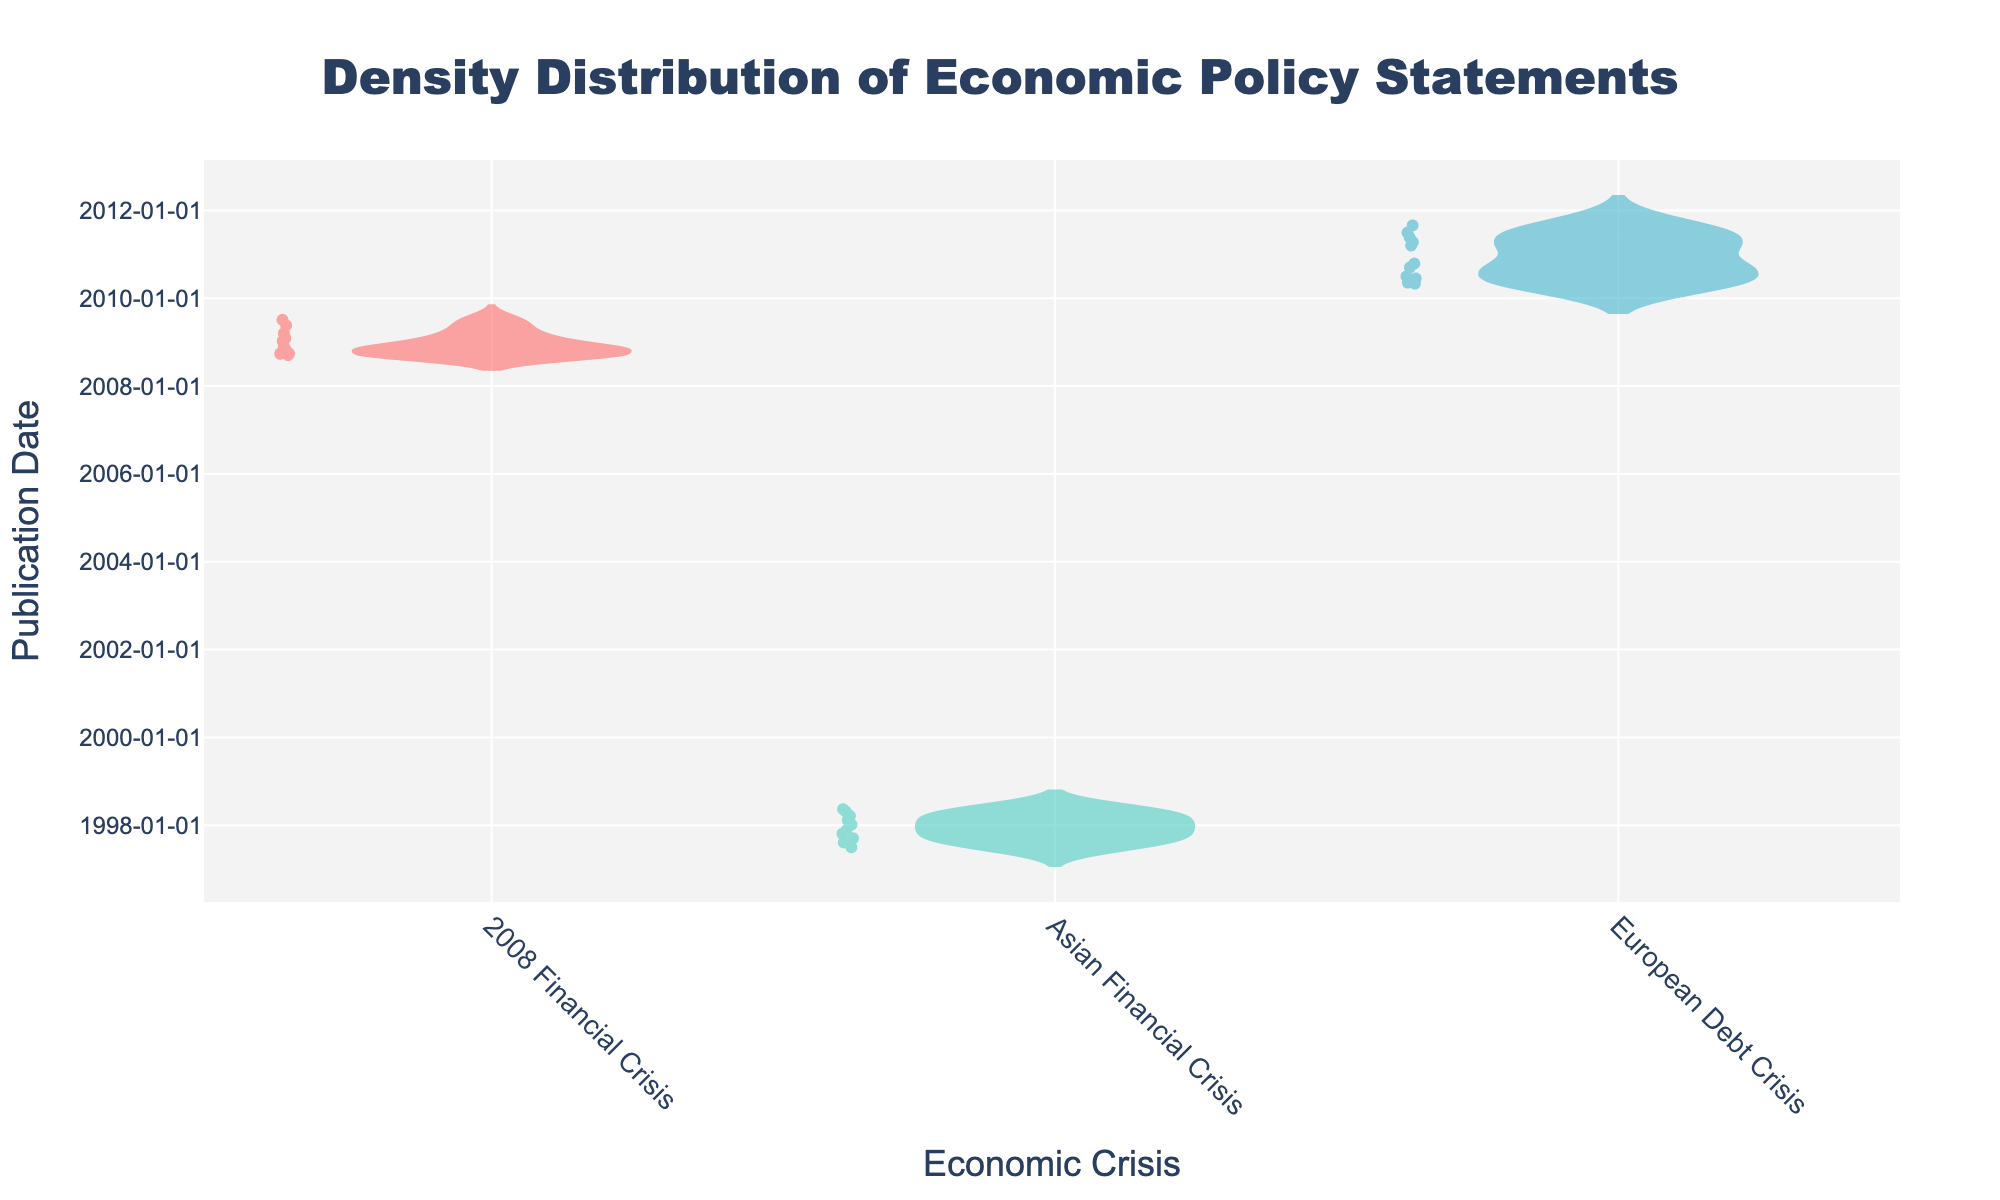What is the title of the plot? The title is displayed at the top of the figure and describes the content of the plot. The title reads "Density Distribution of Economic Policy Statements".
Answer: Density Distribution of Economic Policy Statements How many different economic crises are represented in the plot? The x-axis labels indicate the different economic crises. There are three unique labels: "2008 Financial Crisis," "Asian Financial Crisis," and "European Debt Crisis".
Answer: 3 What colors are used to represent the 2008 Financial Crisis and the Asian Financial Crisis? The plot uses distinct colors for each economic crisis. For the 2008 Financial Crisis, the color used is a shade of red, while the Asian Financial Crisis is represented by a shade of green.
Answer: Red, Green Which economic crisis has policy statements spanning the longest period? By observing the y-axis spread for each category, the Asian Financial Crisis appears to have the widest range in publication dates.
Answer: Asian Financial Crisis What is the median publication date for the European Debt Crisis? The median is marked by the mean line in the density plot. For the European Debt Crisis, this line falls around mid-2010.
Answer: Mid-2010 Are there more policy statements issued at the beginning or at the end of the 2008 Financial Crisis? The density plot's distribution indicates where the concentration of data points lies, showing a higher density of policy statements at the beginning of the 2008 Financial Crisis.
Answer: Beginning How do the distributions of publication dates differ between the 2008 Financial Crisis and the European Debt Crisis? The y-axis spread and density of data points show that the 2008 Financial Crisis has more spread-out dates clustered at the start, while the European Debt Crisis has dates more evenly spaced out over a shorter period.
Answer: More concentrated at start for 2008 Financial Crisis, more evenly spaced for European Debt Crisis What is the approximate gap between the earliest and latest publication dates for the Asian Financial Crisis? By checking the y-axis, the earliest date is mid-1997 and the latest is mid-1998, giving an approximate span of one year.
Answer: One year Which crisis has the least variability in its policy statement publication dates? The European Debt Crisis shows the smallest spread on the y-axis, indicating the least variability.
Answer: European Debt Crisis How do the distributions of publication dates compare between the 2008 Financial Crisis and the Asian Financial Crisis? The 2008 Financial Crisis has a high density of statements in a relatively short period at the beginning, whereas the Asian Financial Crisis has dates more evenly distributed over a longer period.
Answer: More clustered at start for 2008, more evenly distributed for Asian 